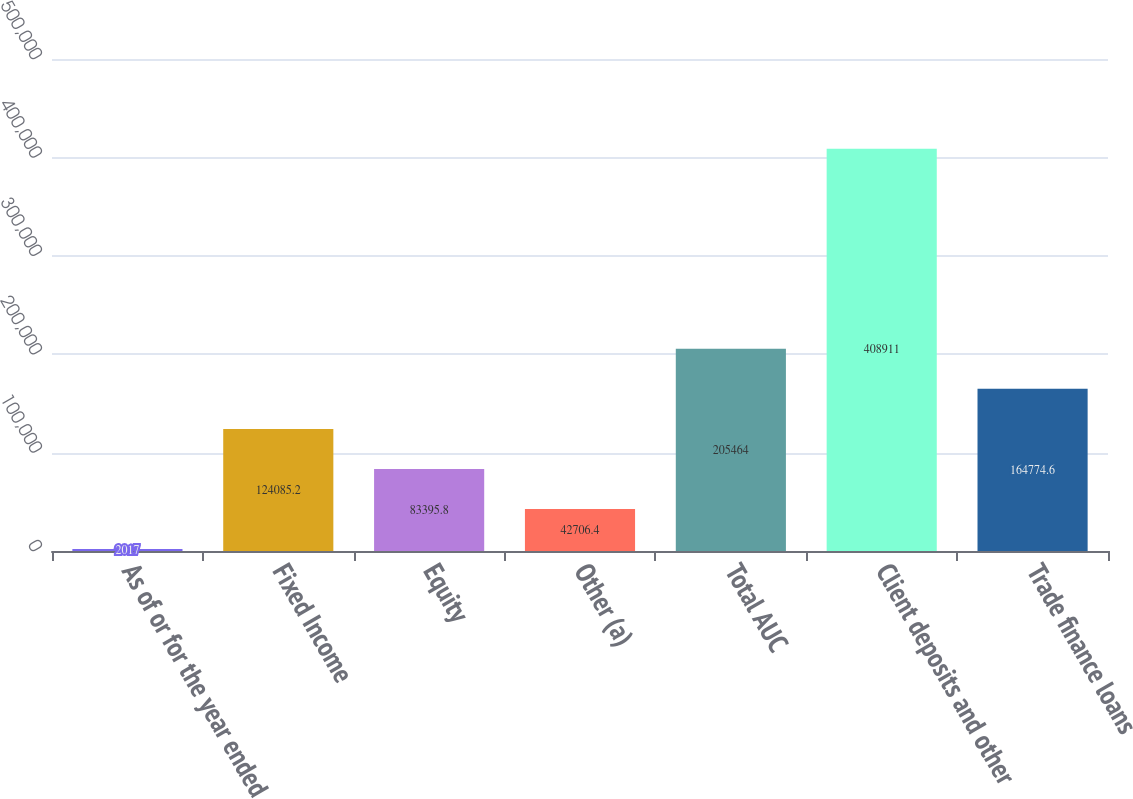<chart> <loc_0><loc_0><loc_500><loc_500><bar_chart><fcel>As of or for the year ended<fcel>Fixed Income<fcel>Equity<fcel>Other (a)<fcel>Total AUC<fcel>Client deposits and other<fcel>Trade finance loans<nl><fcel>2017<fcel>124085<fcel>83395.8<fcel>42706.4<fcel>205464<fcel>408911<fcel>164775<nl></chart> 